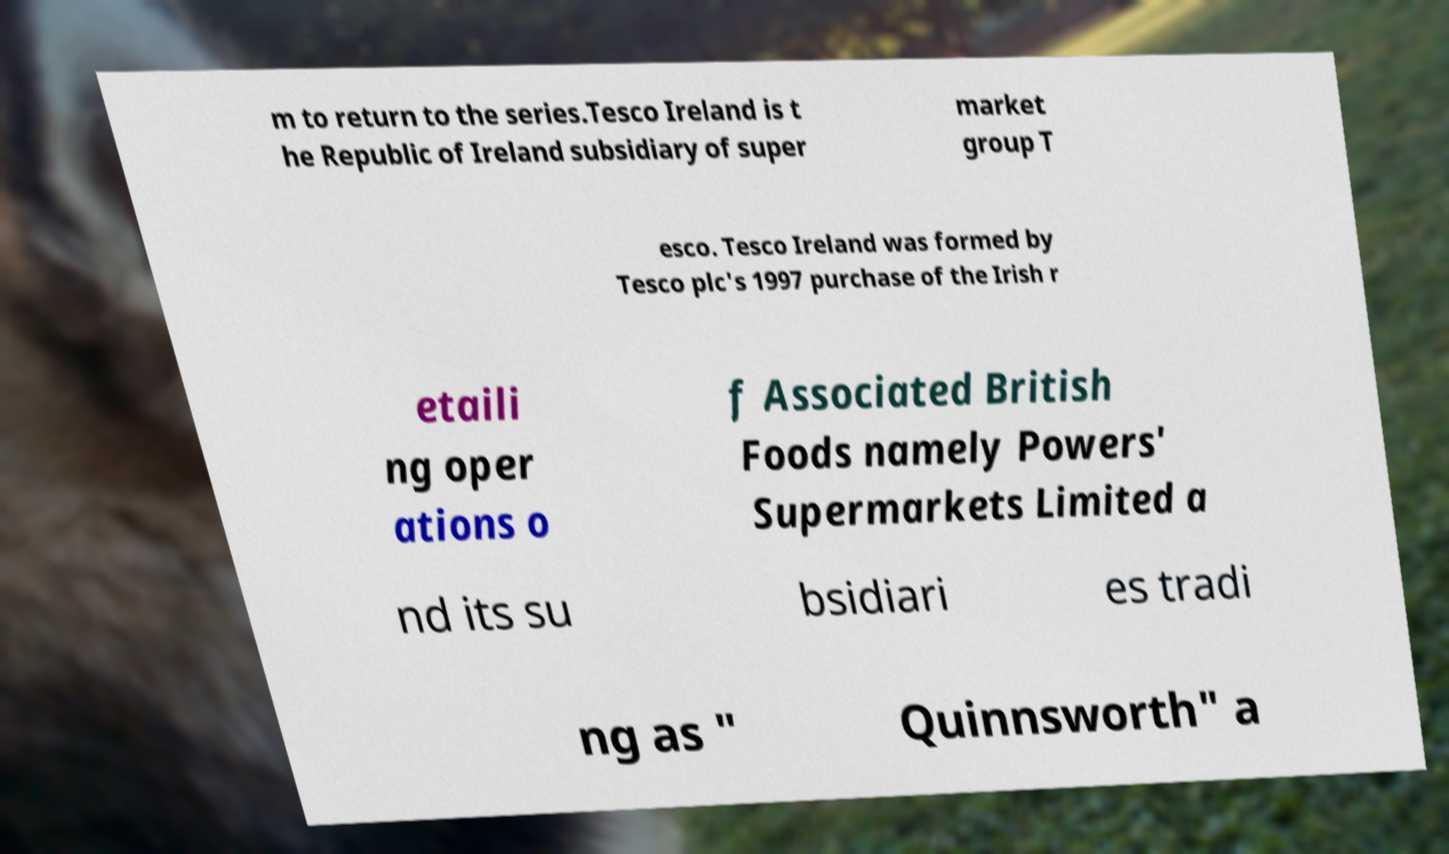What messages or text are displayed in this image? I need them in a readable, typed format. m to return to the series.Tesco Ireland is t he Republic of Ireland subsidiary of super market group T esco. Tesco Ireland was formed by Tesco plc's 1997 purchase of the Irish r etaili ng oper ations o f Associated British Foods namely Powers' Supermarkets Limited a nd its su bsidiari es tradi ng as " Quinnsworth" a 